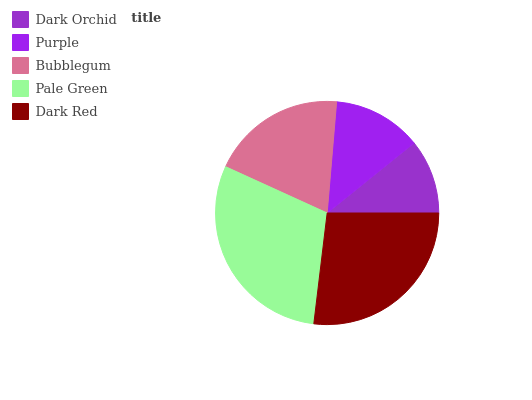Is Dark Orchid the minimum?
Answer yes or no. Yes. Is Pale Green the maximum?
Answer yes or no. Yes. Is Purple the minimum?
Answer yes or no. No. Is Purple the maximum?
Answer yes or no. No. Is Purple greater than Dark Orchid?
Answer yes or no. Yes. Is Dark Orchid less than Purple?
Answer yes or no. Yes. Is Dark Orchid greater than Purple?
Answer yes or no. No. Is Purple less than Dark Orchid?
Answer yes or no. No. Is Bubblegum the high median?
Answer yes or no. Yes. Is Bubblegum the low median?
Answer yes or no. Yes. Is Dark Orchid the high median?
Answer yes or no. No. Is Dark Orchid the low median?
Answer yes or no. No. 